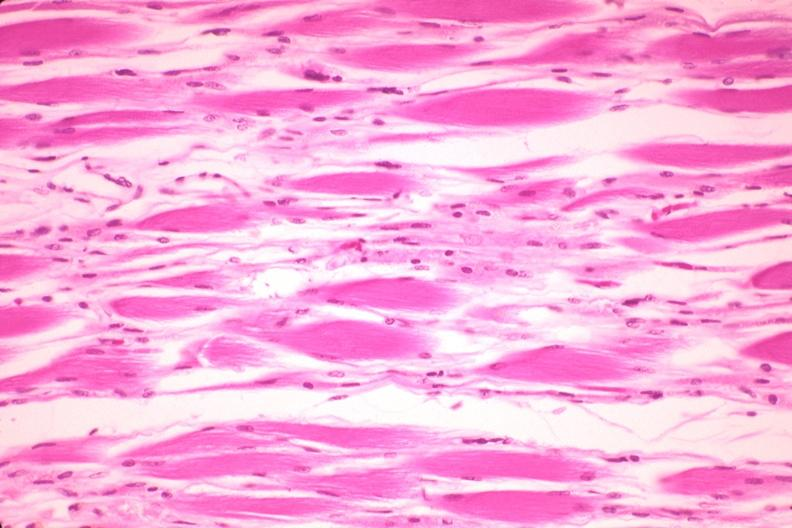s muscle present?
Answer the question using a single word or phrase. Yes 